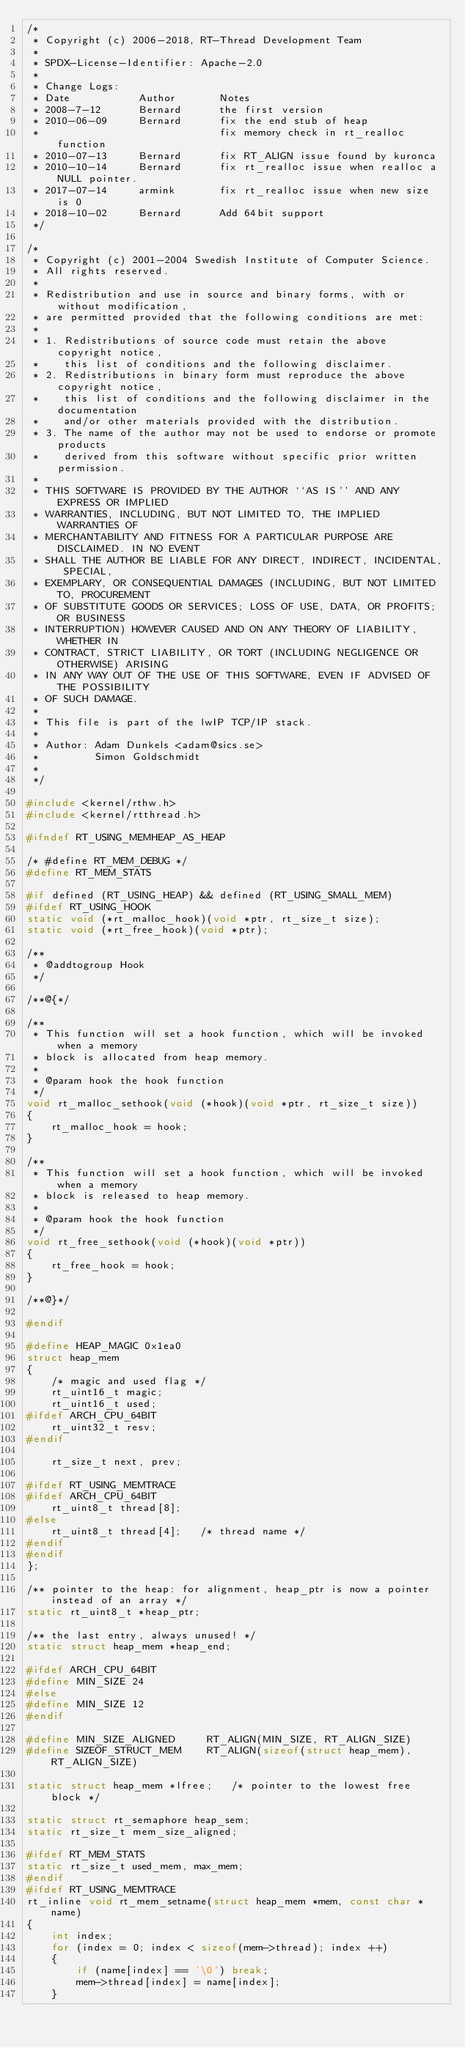<code> <loc_0><loc_0><loc_500><loc_500><_C_>/*
 * Copyright (c) 2006-2018, RT-Thread Development Team
 *
 * SPDX-License-Identifier: Apache-2.0
 *
 * Change Logs:
 * Date           Author       Notes
 * 2008-7-12      Bernard      the first version
 * 2010-06-09     Bernard      fix the end stub of heap
 *                             fix memory check in rt_realloc function
 * 2010-07-13     Bernard      fix RT_ALIGN issue found by kuronca
 * 2010-10-14     Bernard      fix rt_realloc issue when realloc a NULL pointer.
 * 2017-07-14     armink       fix rt_realloc issue when new size is 0
 * 2018-10-02     Bernard      Add 64bit support
 */

/*
 * Copyright (c) 2001-2004 Swedish Institute of Computer Science.
 * All rights reserved.
 *
 * Redistribution and use in source and binary forms, with or without modification,
 * are permitted provided that the following conditions are met:
 *
 * 1. Redistributions of source code must retain the above copyright notice,
 *    this list of conditions and the following disclaimer.
 * 2. Redistributions in binary form must reproduce the above copyright notice,
 *    this list of conditions and the following disclaimer in the documentation
 *    and/or other materials provided with the distribution.
 * 3. The name of the author may not be used to endorse or promote products
 *    derived from this software without specific prior written permission.
 *
 * THIS SOFTWARE IS PROVIDED BY THE AUTHOR ``AS IS'' AND ANY EXPRESS OR IMPLIED
 * WARRANTIES, INCLUDING, BUT NOT LIMITED TO, THE IMPLIED WARRANTIES OF
 * MERCHANTABILITY AND FITNESS FOR A PARTICULAR PURPOSE ARE DISCLAIMED. IN NO EVENT
 * SHALL THE AUTHOR BE LIABLE FOR ANY DIRECT, INDIRECT, INCIDENTAL, SPECIAL,
 * EXEMPLARY, OR CONSEQUENTIAL DAMAGES (INCLUDING, BUT NOT LIMITED TO, PROCUREMENT
 * OF SUBSTITUTE GOODS OR SERVICES; LOSS OF USE, DATA, OR PROFITS; OR BUSINESS
 * INTERRUPTION) HOWEVER CAUSED AND ON ANY THEORY OF LIABILITY, WHETHER IN
 * CONTRACT, STRICT LIABILITY, OR TORT (INCLUDING NEGLIGENCE OR OTHERWISE) ARISING
 * IN ANY WAY OUT OF THE USE OF THIS SOFTWARE, EVEN IF ADVISED OF THE POSSIBILITY
 * OF SUCH DAMAGE.
 *
 * This file is part of the lwIP TCP/IP stack.
 *
 * Author: Adam Dunkels <adam@sics.se>
 *         Simon Goldschmidt
 *
 */

#include <kernel/rthw.h>
#include <kernel/rtthread.h>

#ifndef RT_USING_MEMHEAP_AS_HEAP

/* #define RT_MEM_DEBUG */
#define RT_MEM_STATS

#if defined (RT_USING_HEAP) && defined (RT_USING_SMALL_MEM)
#ifdef RT_USING_HOOK
static void (*rt_malloc_hook)(void *ptr, rt_size_t size);
static void (*rt_free_hook)(void *ptr);

/**
 * @addtogroup Hook
 */

/**@{*/

/**
 * This function will set a hook function, which will be invoked when a memory
 * block is allocated from heap memory.
 *
 * @param hook the hook function
 */
void rt_malloc_sethook(void (*hook)(void *ptr, rt_size_t size))
{
    rt_malloc_hook = hook;
}

/**
 * This function will set a hook function, which will be invoked when a memory
 * block is released to heap memory.
 *
 * @param hook the hook function
 */
void rt_free_sethook(void (*hook)(void *ptr))
{
    rt_free_hook = hook;
}

/**@}*/

#endif

#define HEAP_MAGIC 0x1ea0
struct heap_mem
{
    /* magic and used flag */
    rt_uint16_t magic;
    rt_uint16_t used;
#ifdef ARCH_CPU_64BIT
    rt_uint32_t resv;
#endif

    rt_size_t next, prev;

#ifdef RT_USING_MEMTRACE
#ifdef ARCH_CPU_64BIT
    rt_uint8_t thread[8];
#else
    rt_uint8_t thread[4];   /* thread name */
#endif
#endif
};

/** pointer to the heap: for alignment, heap_ptr is now a pointer instead of an array */
static rt_uint8_t *heap_ptr;

/** the last entry, always unused! */
static struct heap_mem *heap_end;

#ifdef ARCH_CPU_64BIT
#define MIN_SIZE 24
#else
#define MIN_SIZE 12
#endif

#define MIN_SIZE_ALIGNED     RT_ALIGN(MIN_SIZE, RT_ALIGN_SIZE)
#define SIZEOF_STRUCT_MEM    RT_ALIGN(sizeof(struct heap_mem), RT_ALIGN_SIZE)

static struct heap_mem *lfree;   /* pointer to the lowest free block */

static struct rt_semaphore heap_sem;
static rt_size_t mem_size_aligned;

#ifdef RT_MEM_STATS
static rt_size_t used_mem, max_mem;
#endif
#ifdef RT_USING_MEMTRACE
rt_inline void rt_mem_setname(struct heap_mem *mem, const char *name)
{
    int index;
    for (index = 0; index < sizeof(mem->thread); index ++)
    {
        if (name[index] == '\0') break;
        mem->thread[index] = name[index];
    }
</code> 